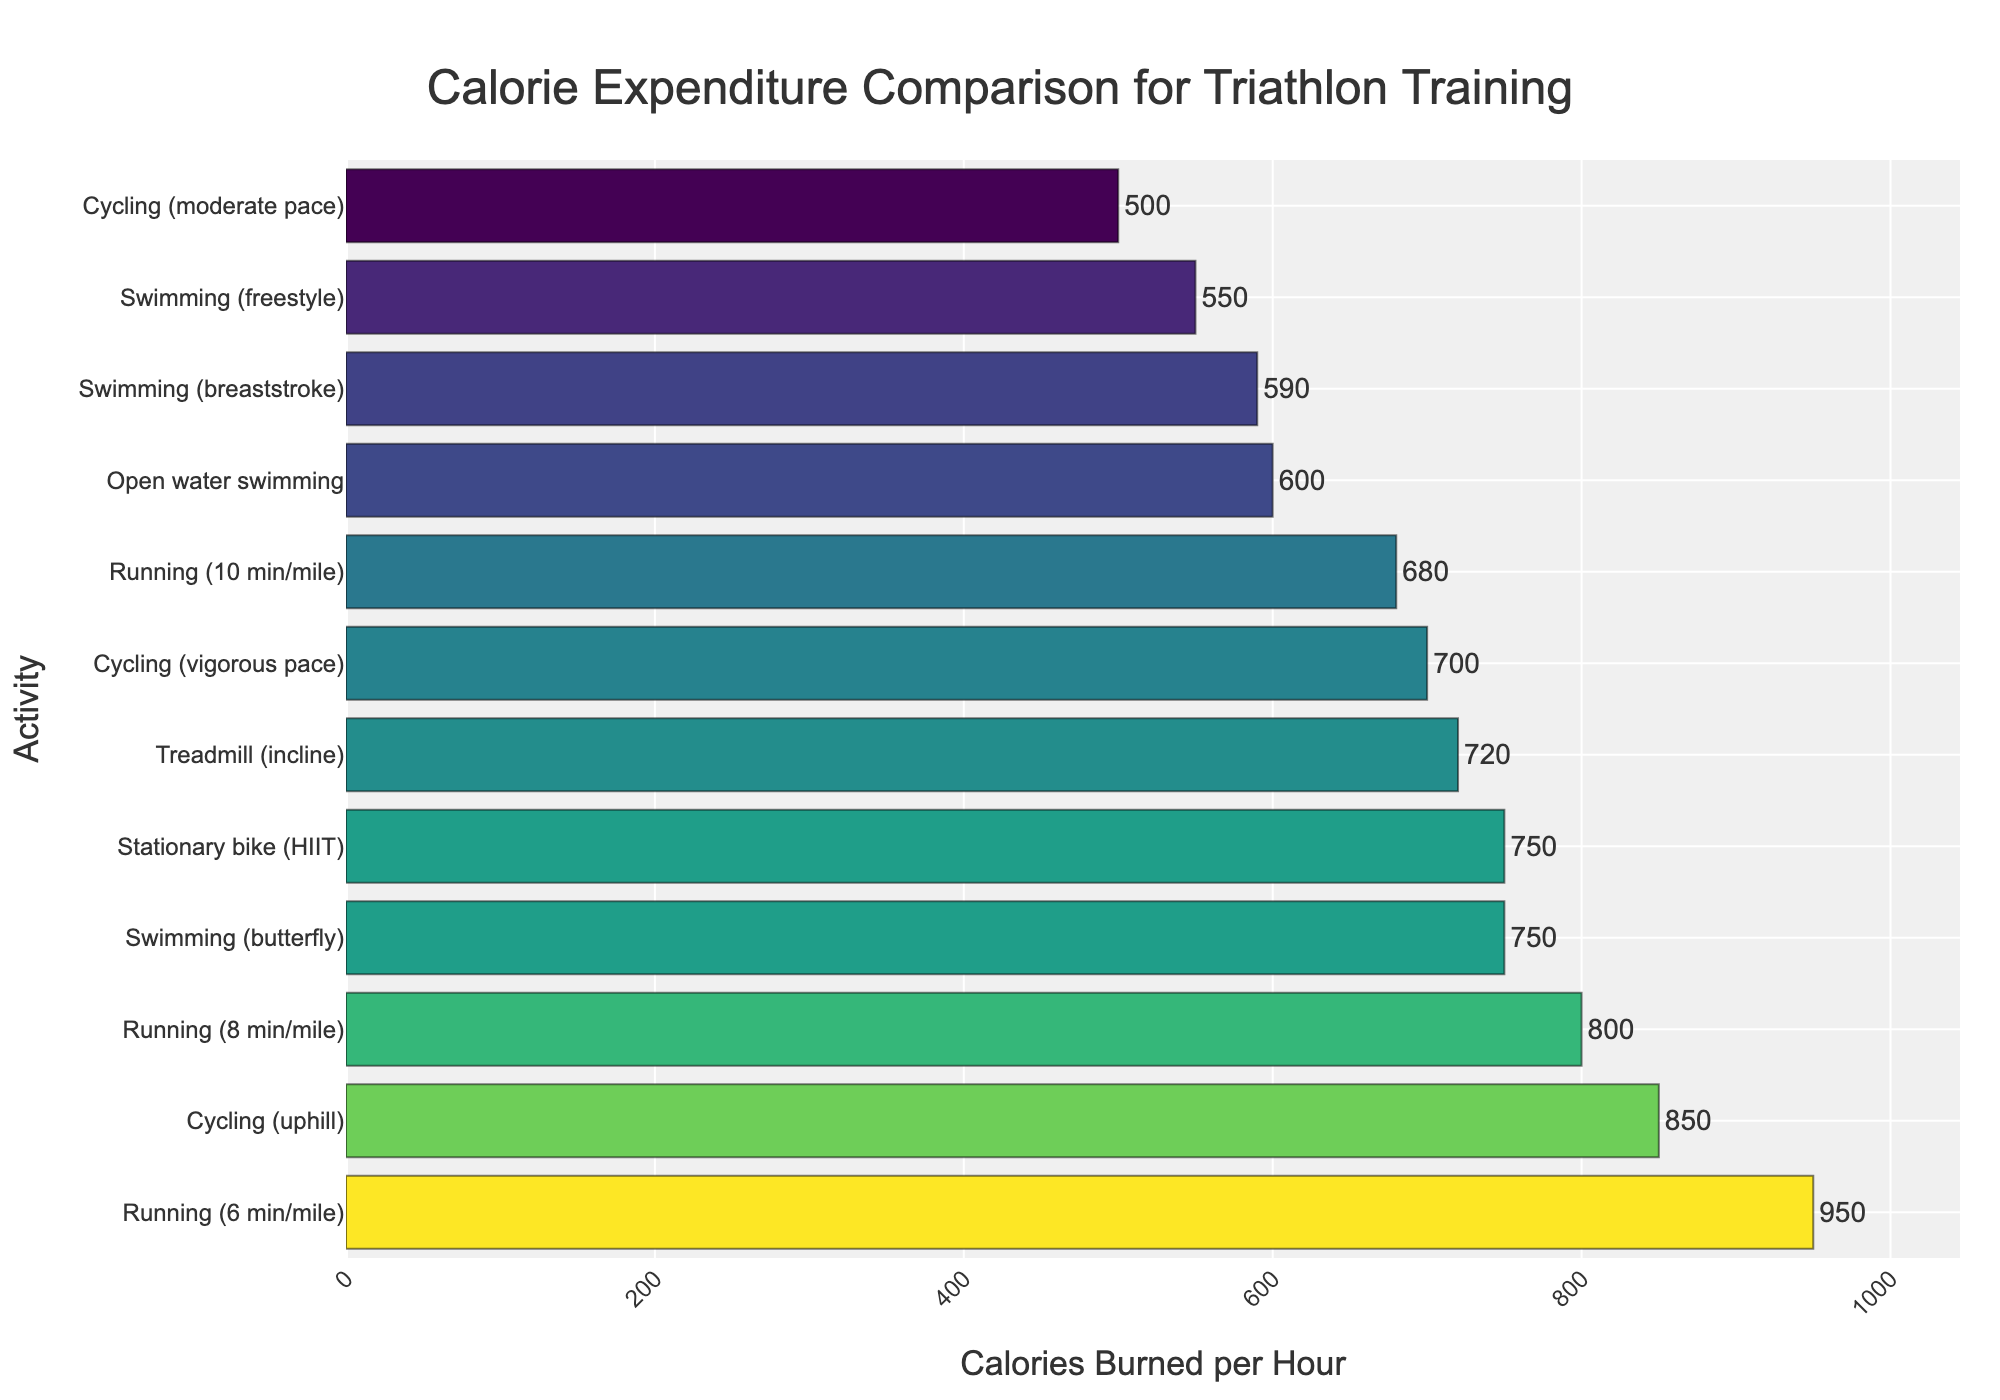Which activity burns the most calories per hour? The figure shows a horizontal bar chart where the y-axis lists different activities and the x-axis shows calories burned per hour. The longest bar represents the activity with the highest calorie expenditure. In this case, the longest bar is for "Running (6 min/mile)" with 950 calories burned per hour.
Answer: Running (6 min/mile) Which activity burns the least calories per hour? The figure shows a horizontal bar chart where the shortest bar represents the activity with the lowest calorie expenditure. The shortest bar corresponds to "Cycling (moderate pace)" with 500 calories burned per hour.
Answer: Cycling (moderate pace) How much more energy does "Running (6 min/mile)" consume compared to "Swimming (freestyle)"? From the chart, "Running (6 min/mile)" burns 950 calories per hour while "Swimming (freestyle)" burns 550 calories per hour. Subtracting the calories for swimming from those for running gives the difference: 950 - 550.
Answer: 400 What is the average calorie expenditure of all running activities? Identify the calorie expenditure for each running activity from the chart: "Running (10 min/mile)" (680), "Running (8 min/mile)" (800), "Running (6 min/mile)" (950), "Treadmill (incline)" (720). Sum these values and divide by the number of running activities: (680 + 800 + 950 + 720) / 4.
Answer: 787.5 Which swimming activity burns the most calories per hour? The figure shows the calorie expenditure for various swimming activities. The longest bar among the swimming activities corresponds to "Swimming (butterfly)" which burns 750 calories per hour.
Answer: Swimming (butterfly) How does the calorie expenditure of "Cycling (vigorous pace)" compare to "Running (10 min/mile)"? The chart shows that "Cycling (vigorous pace)" burns 700 calories per hour and "Running (10 min/mile)" burns 680 calories per hour. Therefore, "Cycling (vigorous pace)" burns 20 calories more per hour than "Running (10 min/mile)".
Answer: 20 more What is the total calorie expenditure for all swimming activities? Identify the calorie expenditure for each swimming activity from the chart: "Swimming (freestyle)" (550), "Swimming (breaststroke)" (590), "Swimming (butterfly)" (750), and "Open water swimming" (600). Sum these values to get the total: 550 + 590 + 750 + 600.
Answer: 2490 What is the median calorie expenditure of all activities listed? First, list all calorie values in ascending order: 500 (Cycling (moderate pace)), 550 (Swimming (freestyle)), 590 (Swimming (breaststroke)), 600 (Open water swimming)), 680 (Running (10 min/mile)), 700 (Cycling (vigorous pace)), 720 (Treadmill (incline)), 750 (Swimming (butterfly)), 750 (Stationary bike (HIIT)), 800 (Running (8 min/mile)), 850 (Cycling (uphill)), 950 (Running (6 min/mile)). Since there are 12 activities, the median is the average of the 6th and 7th values: (700 + 720) / 2.
Answer: 710 What is the difference in calorie expenditure between the most and least energy-consuming activities? Identify the calories burned per hour for the most and least energy-consuming activities from the chart: "Running (6 min/mile)" (950) and "Cycling (moderate pace)" (500). Subtract the latter from the former: 950 - 500.
Answer: 450 